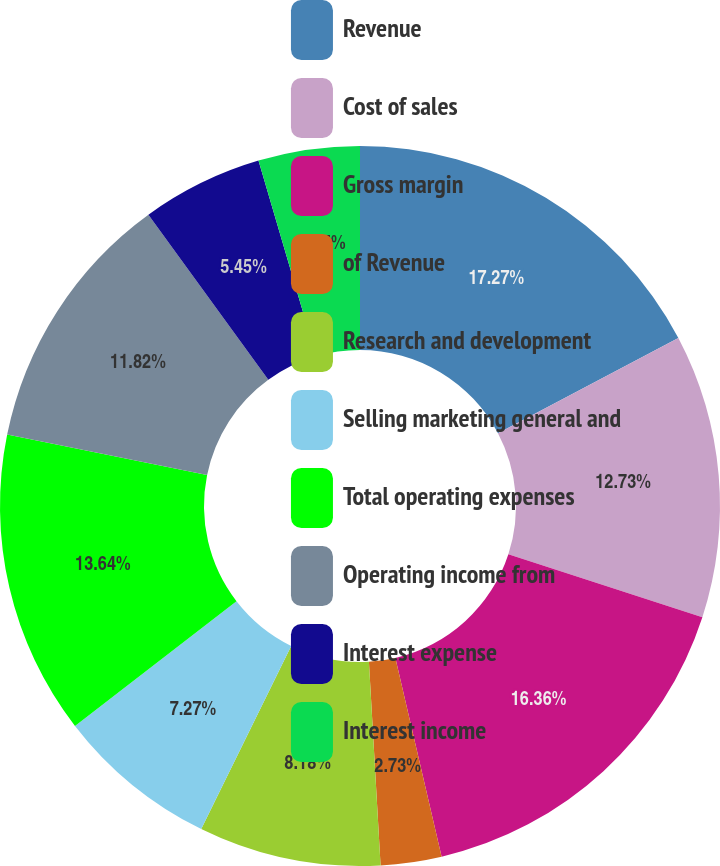Convert chart. <chart><loc_0><loc_0><loc_500><loc_500><pie_chart><fcel>Revenue<fcel>Cost of sales<fcel>Gross margin<fcel>of Revenue<fcel>Research and development<fcel>Selling marketing general and<fcel>Total operating expenses<fcel>Operating income from<fcel>Interest expense<fcel>Interest income<nl><fcel>17.27%<fcel>12.73%<fcel>16.36%<fcel>2.73%<fcel>8.18%<fcel>7.27%<fcel>13.64%<fcel>11.82%<fcel>5.45%<fcel>4.55%<nl></chart> 